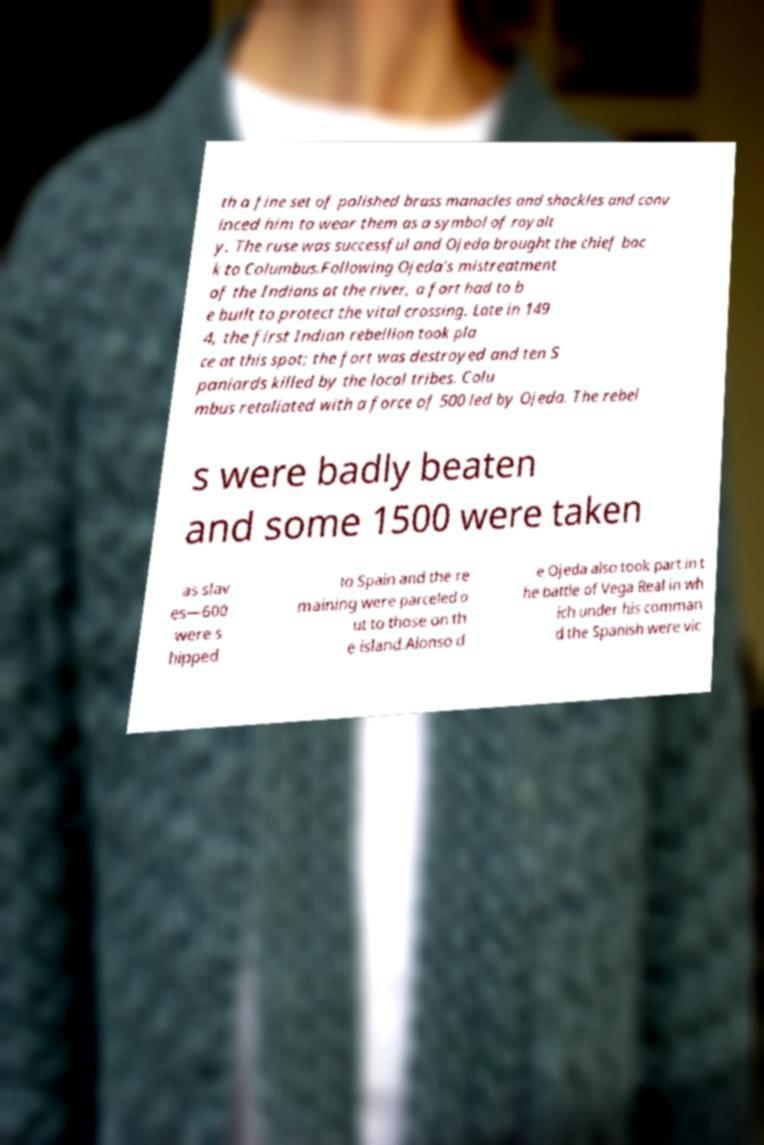There's text embedded in this image that I need extracted. Can you transcribe it verbatim? th a fine set of polished brass manacles and shackles and conv inced him to wear them as a symbol of royalt y. The ruse was successful and Ojeda brought the chief bac k to Columbus.Following Ojeda's mistreatment of the Indians at the river, a fort had to b e built to protect the vital crossing. Late in 149 4, the first Indian rebellion took pla ce at this spot; the fort was destroyed and ten S paniards killed by the local tribes. Colu mbus retaliated with a force of 500 led by Ojeda. The rebel s were badly beaten and some 1500 were taken as slav es—600 were s hipped to Spain and the re maining were parceled o ut to those on th e island.Alonso d e Ojeda also took part in t he battle of Vega Real in wh ich under his comman d the Spanish were vic 